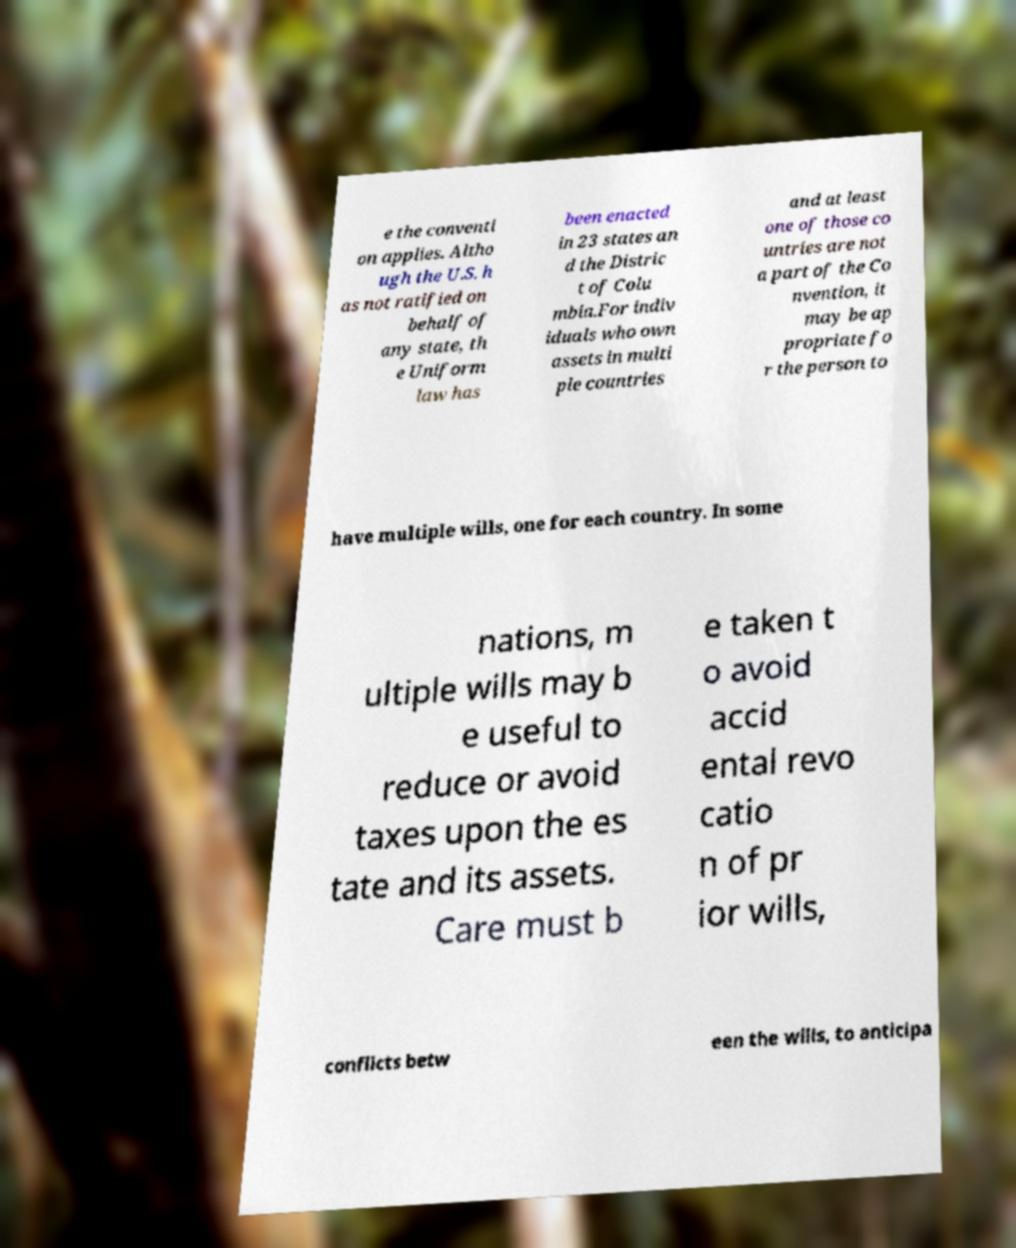Can you read and provide the text displayed in the image?This photo seems to have some interesting text. Can you extract and type it out for me? e the conventi on applies. Altho ugh the U.S. h as not ratified on behalf of any state, th e Uniform law has been enacted in 23 states an d the Distric t of Colu mbia.For indiv iduals who own assets in multi ple countries and at least one of those co untries are not a part of the Co nvention, it may be ap propriate fo r the person to have multiple wills, one for each country. In some nations, m ultiple wills may b e useful to reduce or avoid taxes upon the es tate and its assets. Care must b e taken t o avoid accid ental revo catio n of pr ior wills, conflicts betw een the wills, to anticipa 